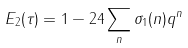<formula> <loc_0><loc_0><loc_500><loc_500>E _ { 2 } ( \tau ) = 1 - 2 4 \sum _ { n } \sigma _ { 1 } ( n ) q ^ { n }</formula> 